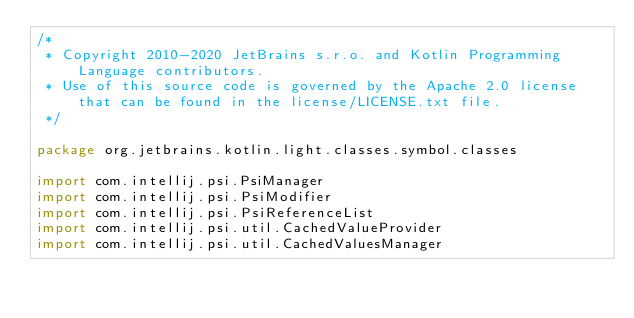<code> <loc_0><loc_0><loc_500><loc_500><_Kotlin_>/*
 * Copyright 2010-2020 JetBrains s.r.o. and Kotlin Programming Language contributors.
 * Use of this source code is governed by the Apache 2.0 license that can be found in the license/LICENSE.txt file.
 */

package org.jetbrains.kotlin.light.classes.symbol.classes

import com.intellij.psi.PsiManager
import com.intellij.psi.PsiModifier
import com.intellij.psi.PsiReferenceList
import com.intellij.psi.util.CachedValueProvider
import com.intellij.psi.util.CachedValuesManager</code> 